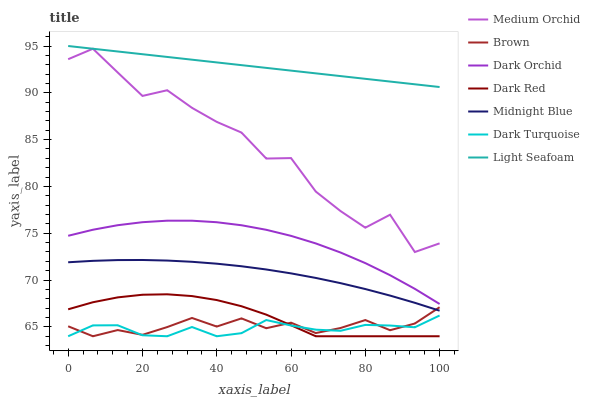Does Midnight Blue have the minimum area under the curve?
Answer yes or no. No. Does Midnight Blue have the maximum area under the curve?
Answer yes or no. No. Is Midnight Blue the smoothest?
Answer yes or no. No. Is Midnight Blue the roughest?
Answer yes or no. No. Does Midnight Blue have the lowest value?
Answer yes or no. No. Does Midnight Blue have the highest value?
Answer yes or no. No. Is Dark Red less than Light Seafoam?
Answer yes or no. Yes. Is Light Seafoam greater than Dark Red?
Answer yes or no. Yes. Does Dark Red intersect Light Seafoam?
Answer yes or no. No. 